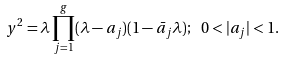<formula> <loc_0><loc_0><loc_500><loc_500>y ^ { 2 } = \lambda \prod _ { j = 1 } ^ { g } ( \lambda - a _ { j } ) ( 1 - \bar { a } _ { j } \lambda ) ; \ 0 < | a _ { j } | < 1 .</formula> 